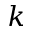<formula> <loc_0><loc_0><loc_500><loc_500>k</formula> 